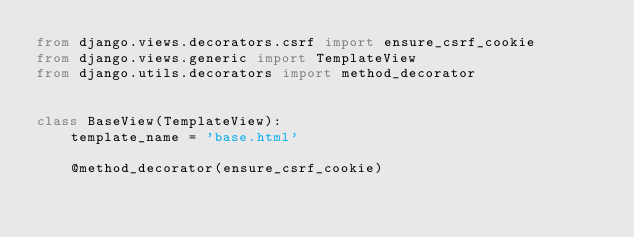<code> <loc_0><loc_0><loc_500><loc_500><_Python_>from django.views.decorators.csrf import ensure_csrf_cookie
from django.views.generic import TemplateView
from django.utils.decorators import method_decorator


class BaseView(TemplateView):
    template_name = 'base.html'

    @method_decorator(ensure_csrf_cookie)</code> 